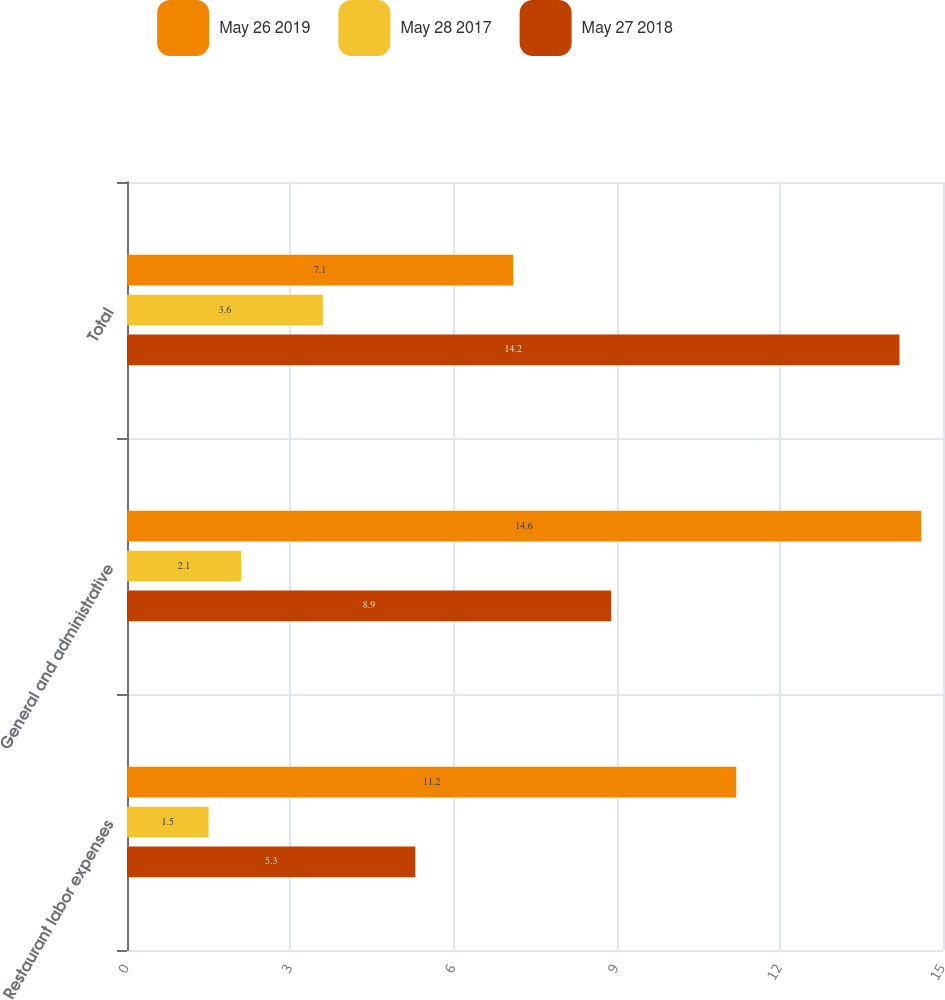Convert chart. <chart><loc_0><loc_0><loc_500><loc_500><stacked_bar_chart><ecel><fcel>Restaurant labor expenses<fcel>General and administrative<fcel>Total<nl><fcel>May 26 2019<fcel>11.2<fcel>14.6<fcel>7.1<nl><fcel>May 28 2017<fcel>1.5<fcel>2.1<fcel>3.6<nl><fcel>May 27 2018<fcel>5.3<fcel>8.9<fcel>14.2<nl></chart> 